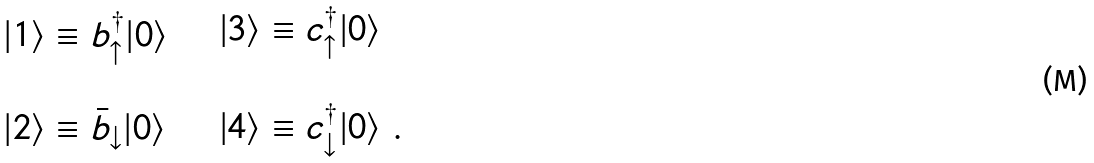Convert formula to latex. <formula><loc_0><loc_0><loc_500><loc_500>\begin{array} { l } | 1 \rangle \equiv b ^ { \dagger } _ { \uparrow } | 0 \rangle \\ \\ | 2 \rangle \equiv \bar { b } _ { \downarrow } | 0 \rangle \end{array} \quad \begin{array} { l } | 3 \rangle \equiv c ^ { \dagger } _ { \uparrow } | 0 \rangle \\ \\ | 4 \rangle \equiv c ^ { \dagger } _ { \downarrow } | 0 \rangle \ . \end{array}</formula> 